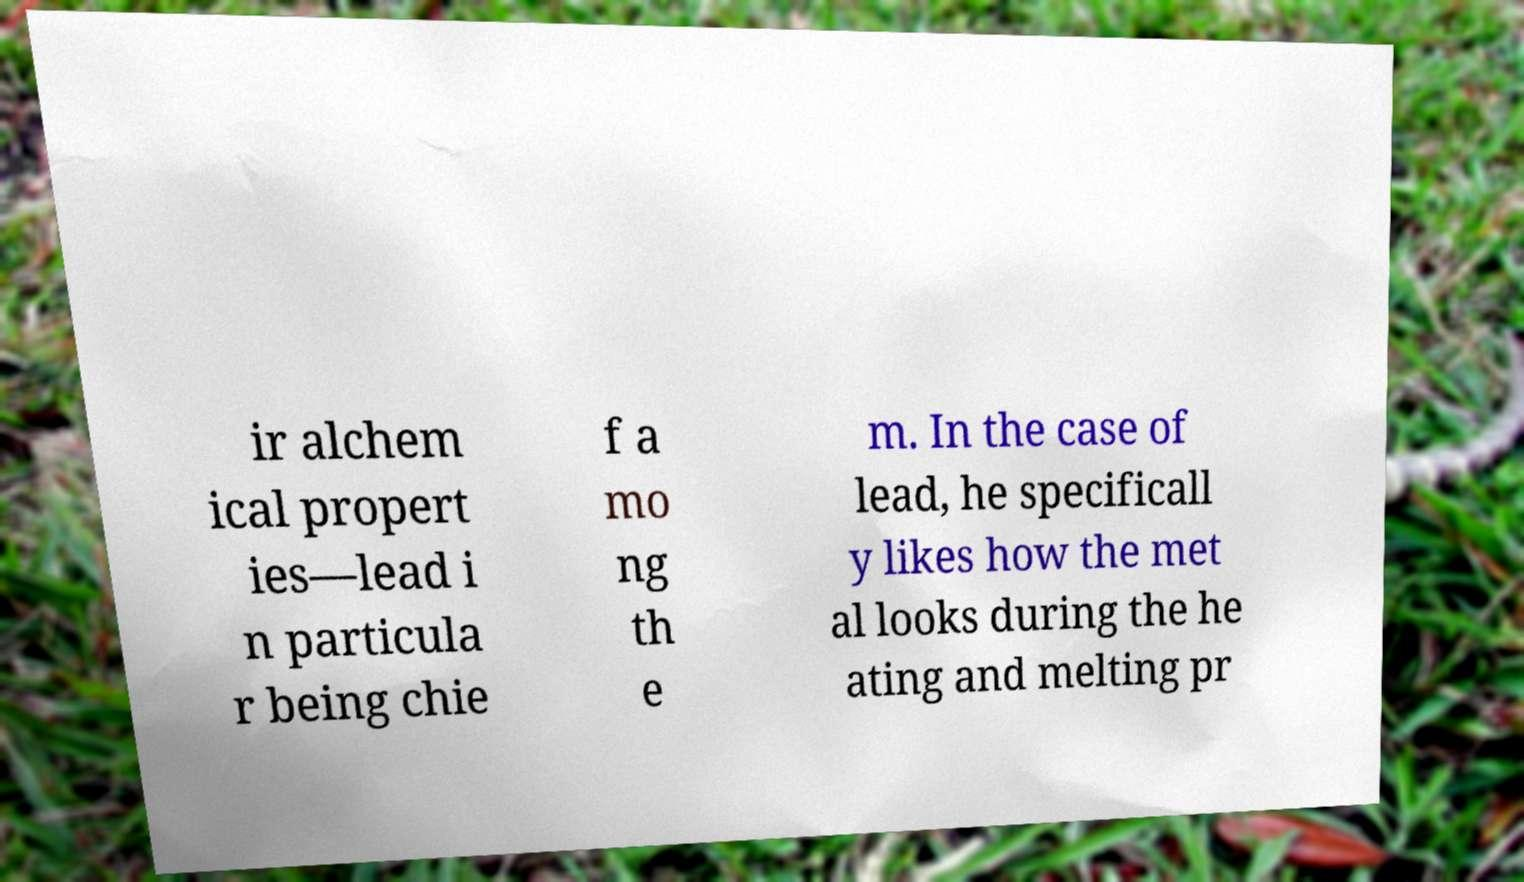Could you assist in decoding the text presented in this image and type it out clearly? ir alchem ical propert ies—lead i n particula r being chie f a mo ng th e m. In the case of lead, he specificall y likes how the met al looks during the he ating and melting pr 